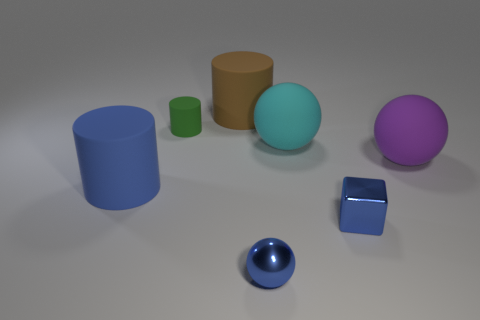There is a blue thing behind the tiny block; what is its material?
Offer a very short reply. Rubber. What number of gray objects are large matte things or balls?
Your answer should be compact. 0. Is the big brown cylinder made of the same material as the big cylinder that is in front of the large purple matte object?
Make the answer very short. Yes. Are there an equal number of large spheres right of the cyan ball and large blue matte objects on the right side of the big blue rubber cylinder?
Keep it short and to the point. No. Do the purple rubber sphere and the ball in front of the large blue matte thing have the same size?
Make the answer very short. No. Is the number of big brown cylinders that are in front of the big purple matte ball greater than the number of large cyan rubber things?
Give a very brief answer. No. What number of other green rubber things have the same size as the green object?
Provide a short and direct response. 0. Does the cylinder left of the small rubber object have the same size as the purple thing in front of the green cylinder?
Your response must be concise. Yes. Is the number of blue metallic balls on the left side of the tiny rubber object greater than the number of large brown matte things on the right side of the blue cube?
Give a very brief answer. No. How many other big brown objects are the same shape as the brown matte thing?
Offer a very short reply. 0. 